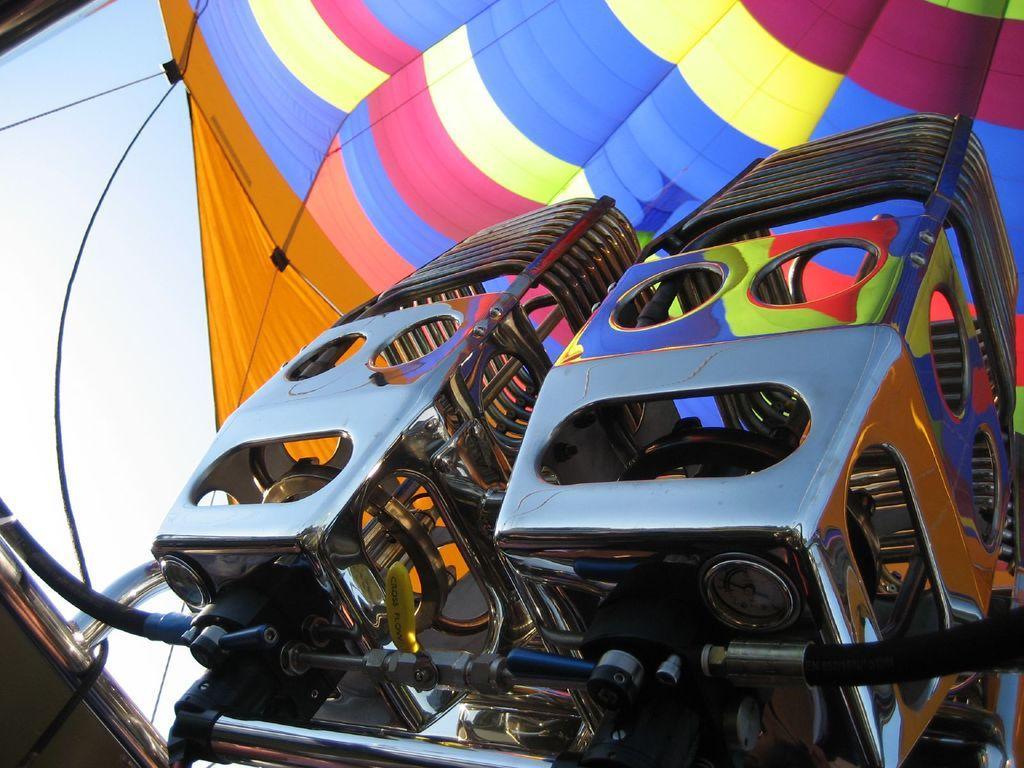Could you give a brief overview of what you see in this image? In this picture we can see few metal objects and an air balloon and in the background we can see the sky. 